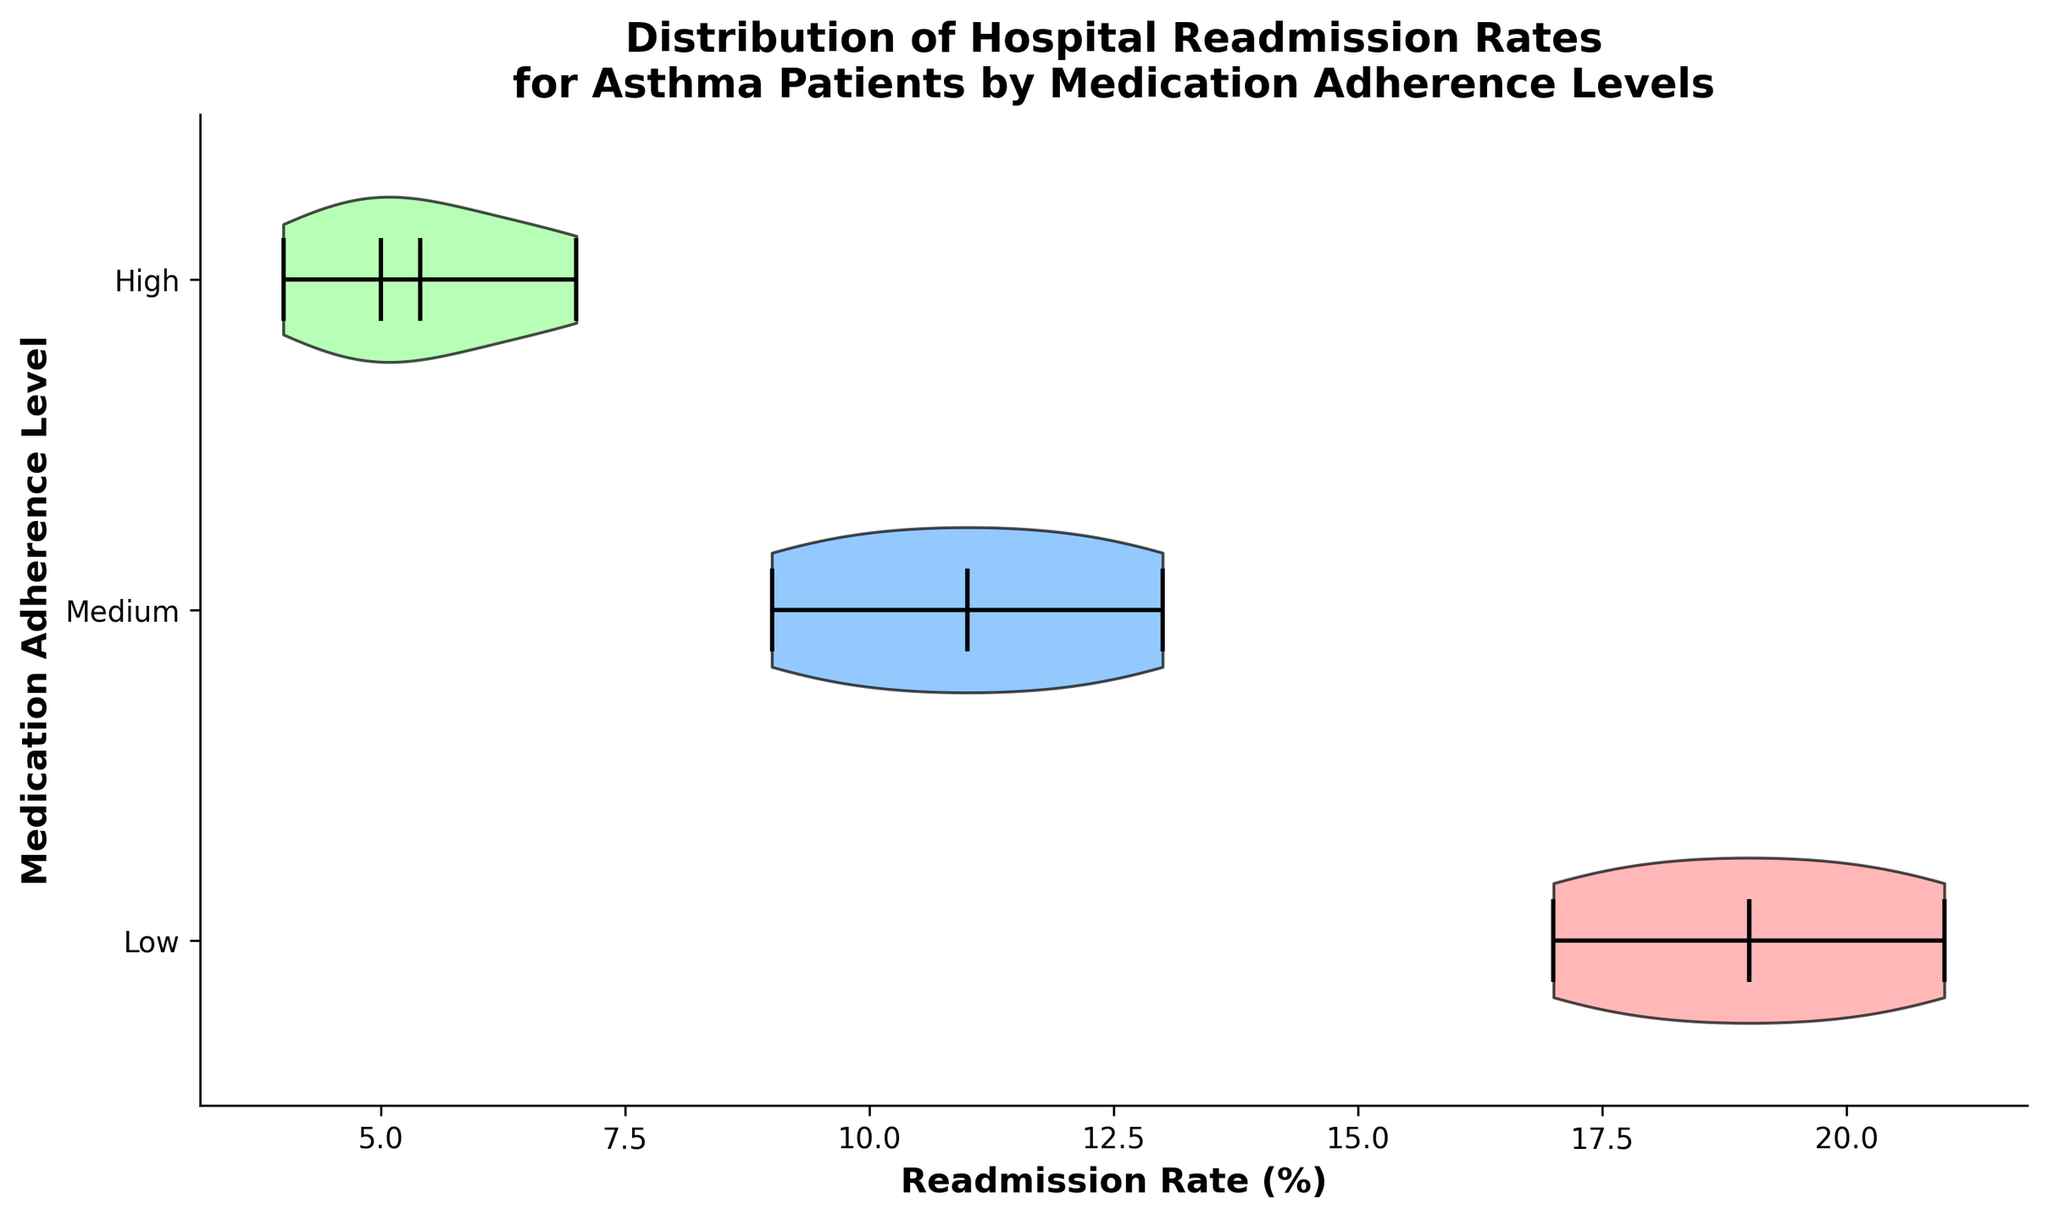What is the title of the figure? The title of the figure is the text at the top that describes what the visualization represents.
Answer: Distribution of Hospital Readmission Rates for Asthma Patients by Medication Adherence Levels How many medication adherence levels are compared in the figure? By looking at the y-axis, we can see the number of distinct labels.
Answer: Three Which adherence level shows the highest median readmission rate? To determine this, we look for the median value, which is indicated by the horizontal line within the violin plot for each adherence level.
Answer: Low What is the mean readmission rate for the “Medium” adherence level? The mean is represented by a dot on the plot. By observing the plot for the "Medium" level, we can see where the dot is located.
Answer: 11 Which adherence level has the smallest range of readmission rates? The range can be identified by looking at the distance between the minimum and maximum values on each violin plot.
Answer: High Compare the maximum readmission rates for "High" and "Low" adherence levels. We look at the highest point on the violin plots for both the "High" and "Low" adherence levels, and compare them.
Answer: "Low" adherence has a higher maximum readmission rate than "High" adherence What is the difference between the mean readmission rate of the High and Low adherence levels? Locate the mean points for both adherence levels and subtract them (mean for High - mean for Low).
Answer: 12 - 5.4 = -6.6 Which adherence level shows the widest distribution of readmission rates? The distribution width is indicated by the width and spread of the violin shape.
Answer: Low What is the interquartile range (IQR) for the "Medium" adherence level? The IQR is the range between the first and third quartiles. On the violin plot, this is often represented by the wider part of the violin.
Answer: Approximately 4 (Between 9 and 13) Is there any adherence level where the mean readmission rate is the same as its median? Check the position of both mean and median indicators for each adherence level to find if they align.
Answer: No 